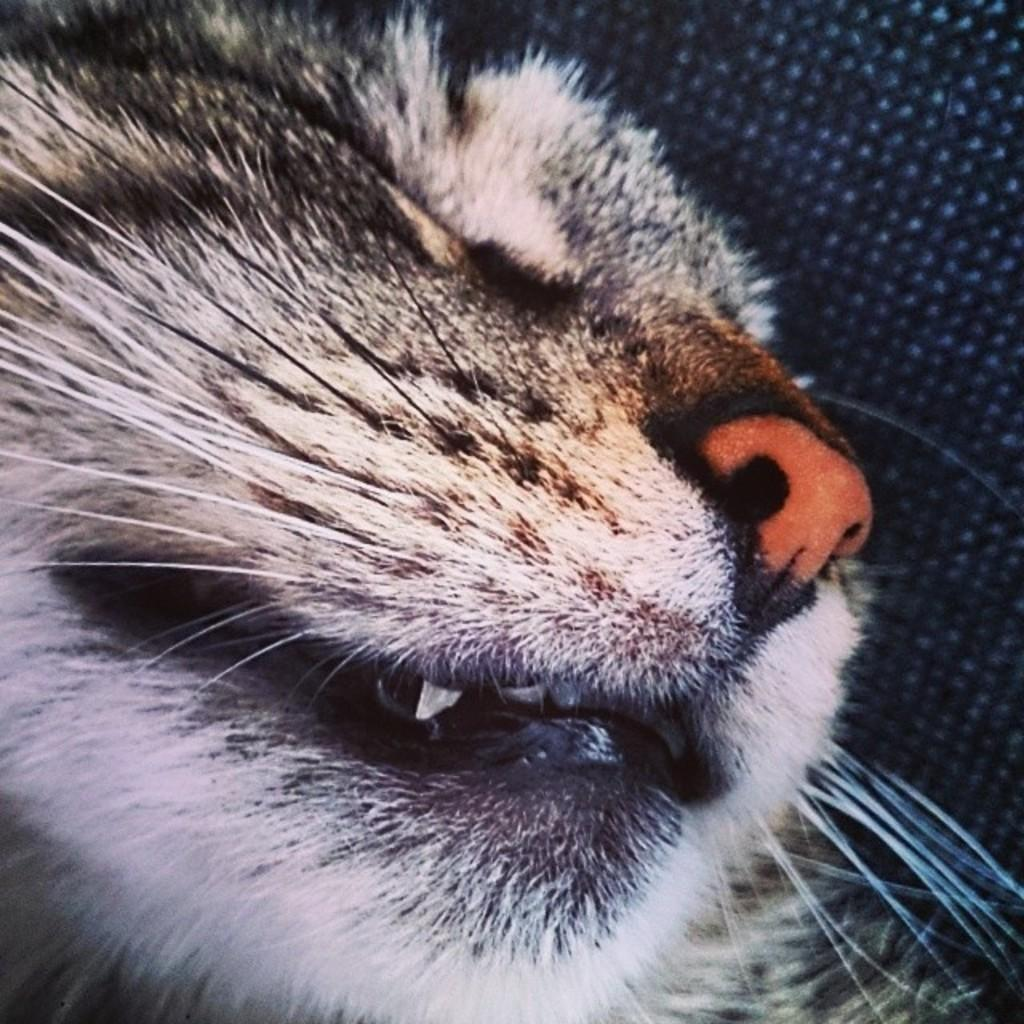What is the main subject of the image? There is a cat's face in the center of the image. How many goats can be seen climbing the tree in the image? There are no goats or trees present in the image; it features a cat's face. 